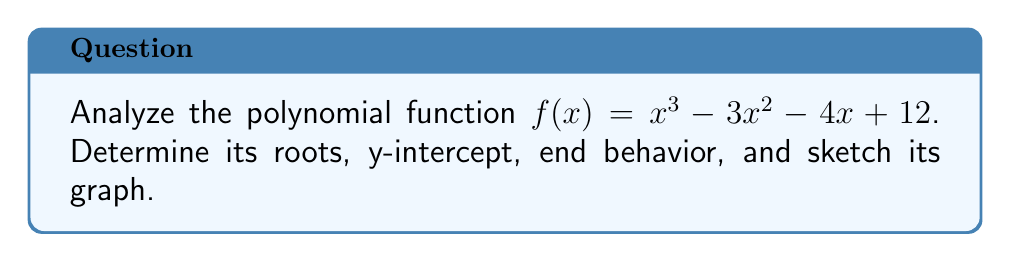Help me with this question. 1. Find the roots:
   Factor the polynomial: $f(x) = (x - 3)(x + 1)(x - 4)$
   Roots are $x = 3, x = -1, x = 4$

2. Find the y-intercept:
   Evaluate $f(0) = 0^3 - 3(0)^2 - 4(0) + 12 = 12$
   Y-intercept is $(0, 12)$

3. Determine end behavior:
   Leading term is $x^3$ (odd degree, positive coefficient)
   As $x \to \infty$, $f(x) \to \infty$
   As $x \to -\infty$, $f(x) \to -\infty$

4. Sketch the graph:
   [asy]
   import graph;
   size(200,200);
   
   real f(real x) {return x^3 - 3x^2 - 4x + 12;}
   
   xaxis("x", Arrow);
   yaxis("y", Arrow);
   
   draw(graph(f,-2,5), blue);
   
   dot((-1,0));
   dot((3,0));
   dot((4,0));
   dot((0,12));
   
   label("(-1,0)", (-1,-0.5), S);
   label("(3,0)", (3,-0.5), S);
   label("(4,0)", (4,-0.5), S);
   label("(0,12)", (0.5,12), E);
   [/asy]

The graph crosses the x-axis at the roots $(-1, 0)$, $(3, 0)$, and $(4, 0)$, passes through the y-intercept $(0, 12)$, and exhibits the expected end behavior.
Answer: Roots: $x = -1, 3, 4$; Y-intercept: $(0, 12)$; End behavior: $f(x) \to \infty$ as $x \to \infty$, $f(x) \to -\infty$ as $x \to -\infty$ 